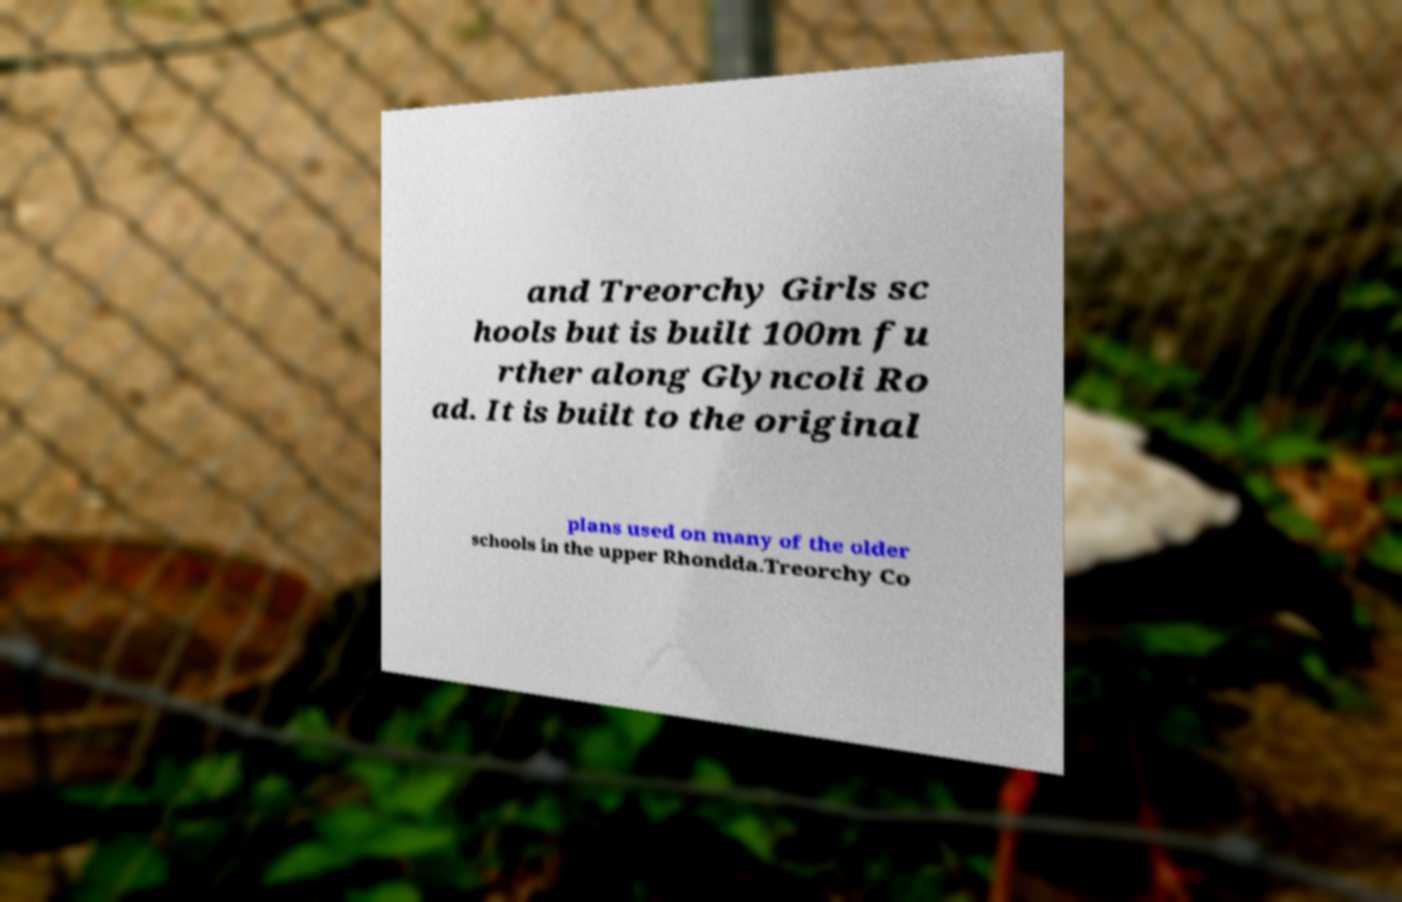Please read and relay the text visible in this image. What does it say? and Treorchy Girls sc hools but is built 100m fu rther along Glyncoli Ro ad. It is built to the original plans used on many of the older schools in the upper Rhondda.Treorchy Co 